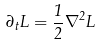Convert formula to latex. <formula><loc_0><loc_0><loc_500><loc_500>\partial _ { t } L = \frac { 1 } { 2 } \nabla ^ { 2 } L</formula> 